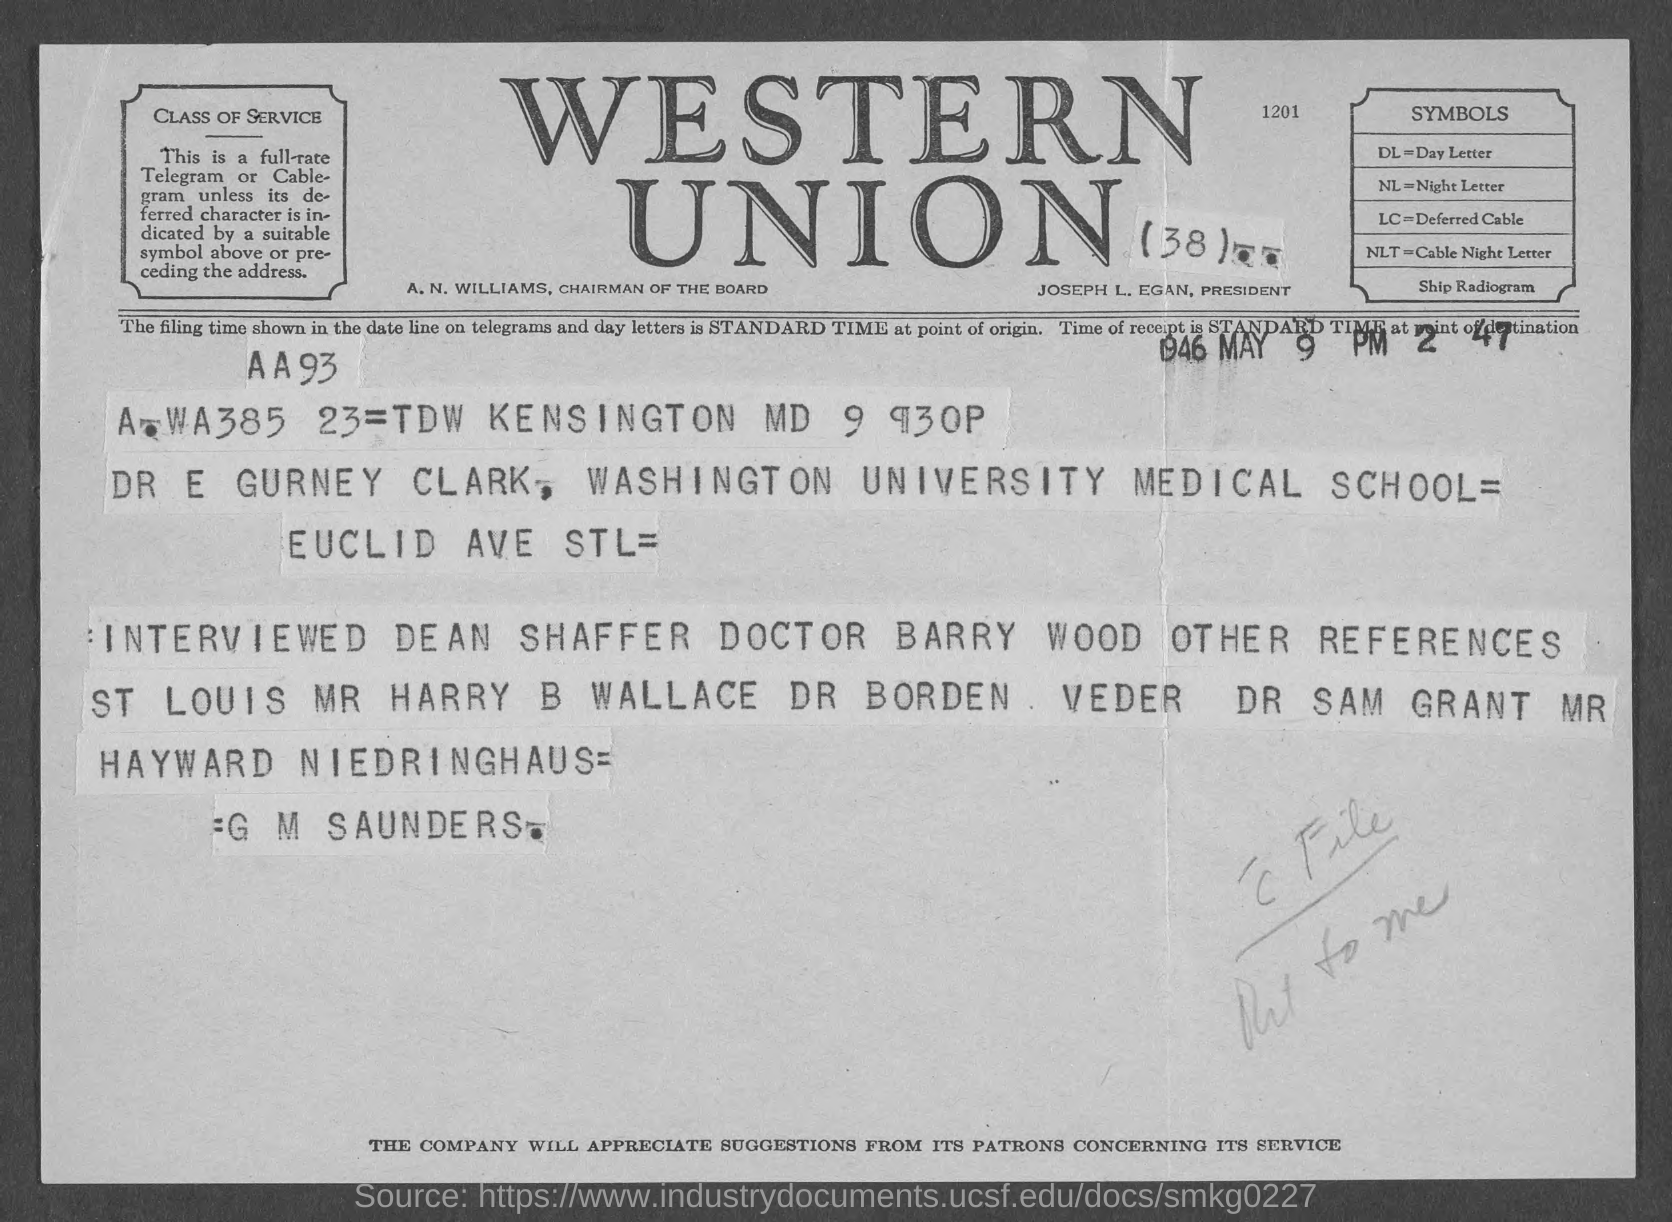List a handful of essential elements in this visual. Night letter" is the fullform of NL. The full form of DL is "Day Letter. The President's name is Joseph L. Egan. 